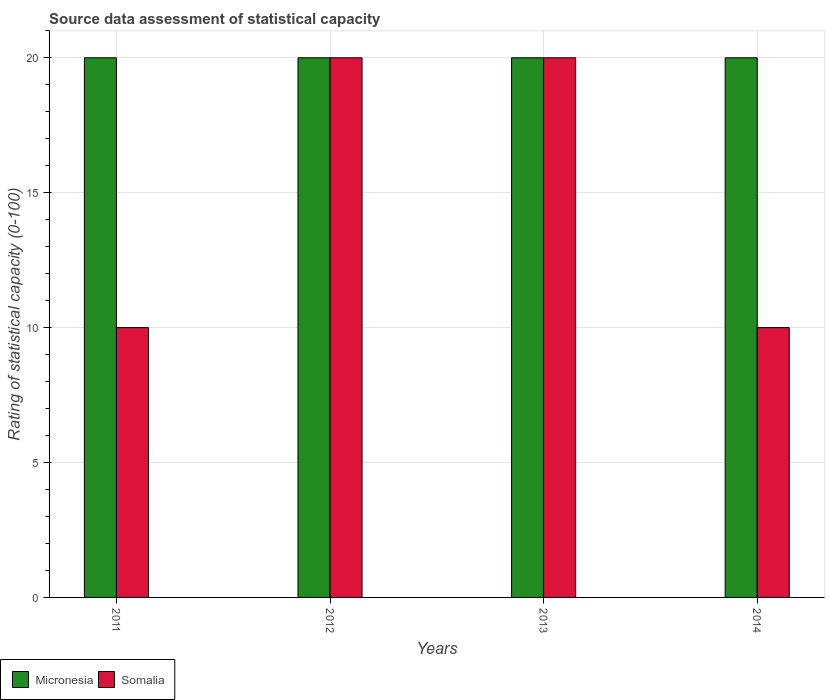How many bars are there on the 1st tick from the left?
Provide a succinct answer. 2. What is the label of the 1st group of bars from the left?
Give a very brief answer. 2011. Across all years, what is the maximum rating of statistical capacity in Somalia?
Provide a succinct answer. 20. Across all years, what is the minimum rating of statistical capacity in Micronesia?
Offer a terse response. 20. In which year was the rating of statistical capacity in Somalia maximum?
Make the answer very short. 2012. In which year was the rating of statistical capacity in Somalia minimum?
Provide a succinct answer. 2011. What is the difference between the rating of statistical capacity in Somalia in 2011 and the rating of statistical capacity in Micronesia in 2014?
Provide a succinct answer. -10. What is the average rating of statistical capacity in Micronesia per year?
Provide a short and direct response. 20. In the year 2013, what is the difference between the rating of statistical capacity in Somalia and rating of statistical capacity in Micronesia?
Make the answer very short. 0. In how many years, is the rating of statistical capacity in Micronesia greater than 14?
Offer a very short reply. 4. What is the ratio of the rating of statistical capacity in Micronesia in 2012 to that in 2013?
Make the answer very short. 1. Is the rating of statistical capacity in Micronesia in 2011 less than that in 2012?
Keep it short and to the point. No. Is the difference between the rating of statistical capacity in Somalia in 2011 and 2014 greater than the difference between the rating of statistical capacity in Micronesia in 2011 and 2014?
Offer a very short reply. No. What does the 2nd bar from the left in 2011 represents?
Make the answer very short. Somalia. What does the 2nd bar from the right in 2014 represents?
Provide a short and direct response. Micronesia. What is the difference between two consecutive major ticks on the Y-axis?
Offer a very short reply. 5. Does the graph contain any zero values?
Offer a terse response. No. Does the graph contain grids?
Make the answer very short. Yes. Where does the legend appear in the graph?
Give a very brief answer. Bottom left. How many legend labels are there?
Make the answer very short. 2. How are the legend labels stacked?
Provide a short and direct response. Horizontal. What is the title of the graph?
Ensure brevity in your answer.  Source data assessment of statistical capacity. What is the label or title of the Y-axis?
Offer a very short reply. Rating of statistical capacity (0-100). What is the Rating of statistical capacity (0-100) of Micronesia in 2011?
Make the answer very short. 20. What is the Rating of statistical capacity (0-100) of Somalia in 2011?
Offer a very short reply. 10. What is the Rating of statistical capacity (0-100) of Somalia in 2014?
Provide a short and direct response. 10. Across all years, what is the maximum Rating of statistical capacity (0-100) in Micronesia?
Provide a succinct answer. 20. Across all years, what is the maximum Rating of statistical capacity (0-100) of Somalia?
Your response must be concise. 20. Across all years, what is the minimum Rating of statistical capacity (0-100) in Micronesia?
Ensure brevity in your answer.  20. Across all years, what is the minimum Rating of statistical capacity (0-100) in Somalia?
Your answer should be compact. 10. What is the difference between the Rating of statistical capacity (0-100) in Micronesia in 2011 and that in 2013?
Offer a very short reply. 0. What is the difference between the Rating of statistical capacity (0-100) of Micronesia in 2011 and the Rating of statistical capacity (0-100) of Somalia in 2013?
Keep it short and to the point. 0. What is the difference between the Rating of statistical capacity (0-100) in Micronesia in 2011 and the Rating of statistical capacity (0-100) in Somalia in 2014?
Ensure brevity in your answer.  10. What is the average Rating of statistical capacity (0-100) of Micronesia per year?
Offer a terse response. 20. In the year 2011, what is the difference between the Rating of statistical capacity (0-100) of Micronesia and Rating of statistical capacity (0-100) of Somalia?
Your answer should be very brief. 10. In the year 2013, what is the difference between the Rating of statistical capacity (0-100) of Micronesia and Rating of statistical capacity (0-100) of Somalia?
Provide a short and direct response. 0. What is the ratio of the Rating of statistical capacity (0-100) of Somalia in 2011 to that in 2013?
Give a very brief answer. 0.5. What is the ratio of the Rating of statistical capacity (0-100) of Somalia in 2012 to that in 2013?
Ensure brevity in your answer.  1. What is the ratio of the Rating of statistical capacity (0-100) of Somalia in 2012 to that in 2014?
Offer a very short reply. 2. What is the ratio of the Rating of statistical capacity (0-100) in Somalia in 2013 to that in 2014?
Make the answer very short. 2. What is the difference between the highest and the second highest Rating of statistical capacity (0-100) in Micronesia?
Your answer should be very brief. 0. 